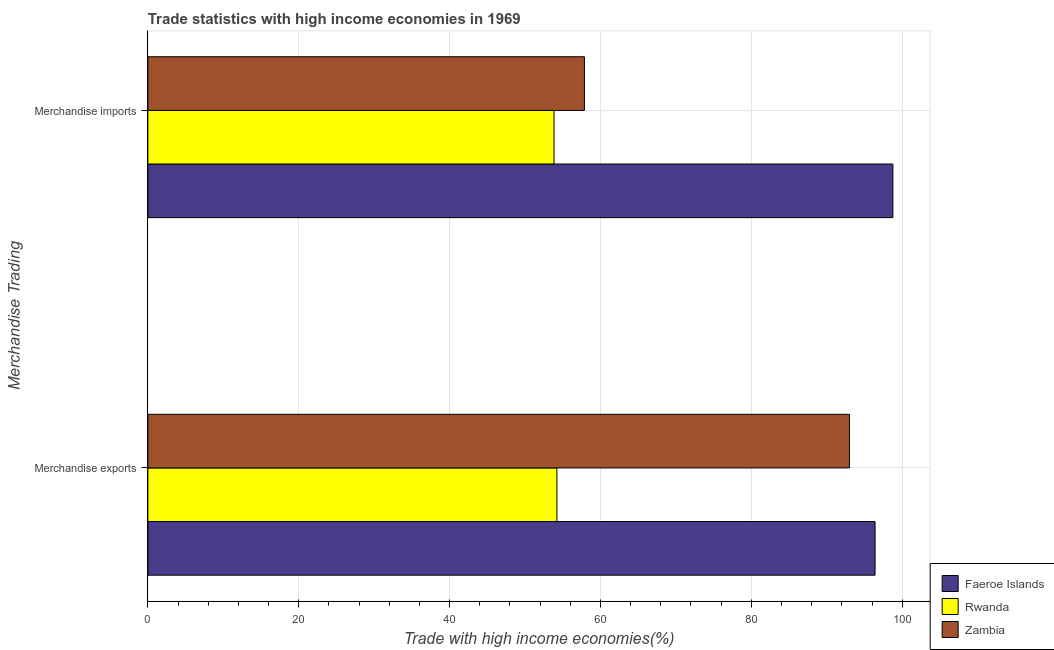How many different coloured bars are there?
Keep it short and to the point. 3. Are the number of bars per tick equal to the number of legend labels?
Provide a short and direct response. Yes. Are the number of bars on each tick of the Y-axis equal?
Offer a terse response. Yes. How many bars are there on the 2nd tick from the top?
Your response must be concise. 3. What is the label of the 1st group of bars from the top?
Offer a terse response. Merchandise imports. What is the merchandise exports in Faeroe Islands?
Give a very brief answer. 96.41. Across all countries, what is the maximum merchandise imports?
Offer a terse response. 98.77. Across all countries, what is the minimum merchandise imports?
Offer a terse response. 53.85. In which country was the merchandise exports maximum?
Keep it short and to the point. Faeroe Islands. In which country was the merchandise imports minimum?
Give a very brief answer. Rwanda. What is the total merchandise imports in the graph?
Offer a very short reply. 210.49. What is the difference between the merchandise exports in Faeroe Islands and that in Zambia?
Provide a succinct answer. 3.4. What is the difference between the merchandise imports in Rwanda and the merchandise exports in Zambia?
Give a very brief answer. -39.16. What is the average merchandise exports per country?
Give a very brief answer. 81.21. What is the difference between the merchandise exports and merchandise imports in Faeroe Islands?
Give a very brief answer. -2.37. In how many countries, is the merchandise exports greater than 12 %?
Offer a very short reply. 3. What is the ratio of the merchandise exports in Zambia to that in Rwanda?
Your response must be concise. 1.72. In how many countries, is the merchandise exports greater than the average merchandise exports taken over all countries?
Your answer should be very brief. 2. What does the 3rd bar from the top in Merchandise exports represents?
Your answer should be very brief. Faeroe Islands. What does the 1st bar from the bottom in Merchandise exports represents?
Provide a short and direct response. Faeroe Islands. How many countries are there in the graph?
Give a very brief answer. 3. What is the difference between two consecutive major ticks on the X-axis?
Offer a terse response. 20. How many legend labels are there?
Give a very brief answer. 3. How are the legend labels stacked?
Provide a succinct answer. Vertical. What is the title of the graph?
Provide a succinct answer. Trade statistics with high income economies in 1969. Does "Pakistan" appear as one of the legend labels in the graph?
Keep it short and to the point. No. What is the label or title of the X-axis?
Provide a succinct answer. Trade with high income economies(%). What is the label or title of the Y-axis?
Give a very brief answer. Merchandise Trading. What is the Trade with high income economies(%) of Faeroe Islands in Merchandise exports?
Provide a short and direct response. 96.41. What is the Trade with high income economies(%) in Rwanda in Merchandise exports?
Provide a short and direct response. 54.23. What is the Trade with high income economies(%) of Zambia in Merchandise exports?
Make the answer very short. 93. What is the Trade with high income economies(%) of Faeroe Islands in Merchandise imports?
Offer a very short reply. 98.77. What is the Trade with high income economies(%) of Rwanda in Merchandise imports?
Make the answer very short. 53.85. What is the Trade with high income economies(%) of Zambia in Merchandise imports?
Provide a short and direct response. 57.87. Across all Merchandise Trading, what is the maximum Trade with high income economies(%) in Faeroe Islands?
Keep it short and to the point. 98.77. Across all Merchandise Trading, what is the maximum Trade with high income economies(%) in Rwanda?
Ensure brevity in your answer.  54.23. Across all Merchandise Trading, what is the maximum Trade with high income economies(%) in Zambia?
Your response must be concise. 93. Across all Merchandise Trading, what is the minimum Trade with high income economies(%) in Faeroe Islands?
Your answer should be compact. 96.41. Across all Merchandise Trading, what is the minimum Trade with high income economies(%) of Rwanda?
Keep it short and to the point. 53.85. Across all Merchandise Trading, what is the minimum Trade with high income economies(%) in Zambia?
Ensure brevity in your answer.  57.87. What is the total Trade with high income economies(%) of Faeroe Islands in the graph?
Offer a very short reply. 195.18. What is the total Trade with high income economies(%) in Rwanda in the graph?
Ensure brevity in your answer.  108.07. What is the total Trade with high income economies(%) of Zambia in the graph?
Ensure brevity in your answer.  150.88. What is the difference between the Trade with high income economies(%) of Faeroe Islands in Merchandise exports and that in Merchandise imports?
Your response must be concise. -2.37. What is the difference between the Trade with high income economies(%) of Rwanda in Merchandise exports and that in Merchandise imports?
Your answer should be very brief. 0.38. What is the difference between the Trade with high income economies(%) of Zambia in Merchandise exports and that in Merchandise imports?
Offer a very short reply. 35.13. What is the difference between the Trade with high income economies(%) in Faeroe Islands in Merchandise exports and the Trade with high income economies(%) in Rwanda in Merchandise imports?
Provide a short and direct response. 42.56. What is the difference between the Trade with high income economies(%) of Faeroe Islands in Merchandise exports and the Trade with high income economies(%) of Zambia in Merchandise imports?
Offer a very short reply. 38.53. What is the difference between the Trade with high income economies(%) in Rwanda in Merchandise exports and the Trade with high income economies(%) in Zambia in Merchandise imports?
Your answer should be compact. -3.65. What is the average Trade with high income economies(%) of Faeroe Islands per Merchandise Trading?
Make the answer very short. 97.59. What is the average Trade with high income economies(%) in Rwanda per Merchandise Trading?
Ensure brevity in your answer.  54.04. What is the average Trade with high income economies(%) of Zambia per Merchandise Trading?
Your response must be concise. 75.44. What is the difference between the Trade with high income economies(%) in Faeroe Islands and Trade with high income economies(%) in Rwanda in Merchandise exports?
Provide a short and direct response. 42.18. What is the difference between the Trade with high income economies(%) in Faeroe Islands and Trade with high income economies(%) in Zambia in Merchandise exports?
Offer a very short reply. 3.4. What is the difference between the Trade with high income economies(%) of Rwanda and Trade with high income economies(%) of Zambia in Merchandise exports?
Provide a succinct answer. -38.78. What is the difference between the Trade with high income economies(%) of Faeroe Islands and Trade with high income economies(%) of Rwanda in Merchandise imports?
Offer a very short reply. 44.93. What is the difference between the Trade with high income economies(%) in Faeroe Islands and Trade with high income economies(%) in Zambia in Merchandise imports?
Provide a succinct answer. 40.9. What is the difference between the Trade with high income economies(%) in Rwanda and Trade with high income economies(%) in Zambia in Merchandise imports?
Make the answer very short. -4.03. What is the ratio of the Trade with high income economies(%) in Faeroe Islands in Merchandise exports to that in Merchandise imports?
Make the answer very short. 0.98. What is the ratio of the Trade with high income economies(%) of Rwanda in Merchandise exports to that in Merchandise imports?
Keep it short and to the point. 1.01. What is the ratio of the Trade with high income economies(%) in Zambia in Merchandise exports to that in Merchandise imports?
Offer a terse response. 1.61. What is the difference between the highest and the second highest Trade with high income economies(%) in Faeroe Islands?
Provide a succinct answer. 2.37. What is the difference between the highest and the second highest Trade with high income economies(%) in Rwanda?
Make the answer very short. 0.38. What is the difference between the highest and the second highest Trade with high income economies(%) of Zambia?
Provide a succinct answer. 35.13. What is the difference between the highest and the lowest Trade with high income economies(%) in Faeroe Islands?
Offer a very short reply. 2.37. What is the difference between the highest and the lowest Trade with high income economies(%) in Rwanda?
Provide a short and direct response. 0.38. What is the difference between the highest and the lowest Trade with high income economies(%) in Zambia?
Ensure brevity in your answer.  35.13. 